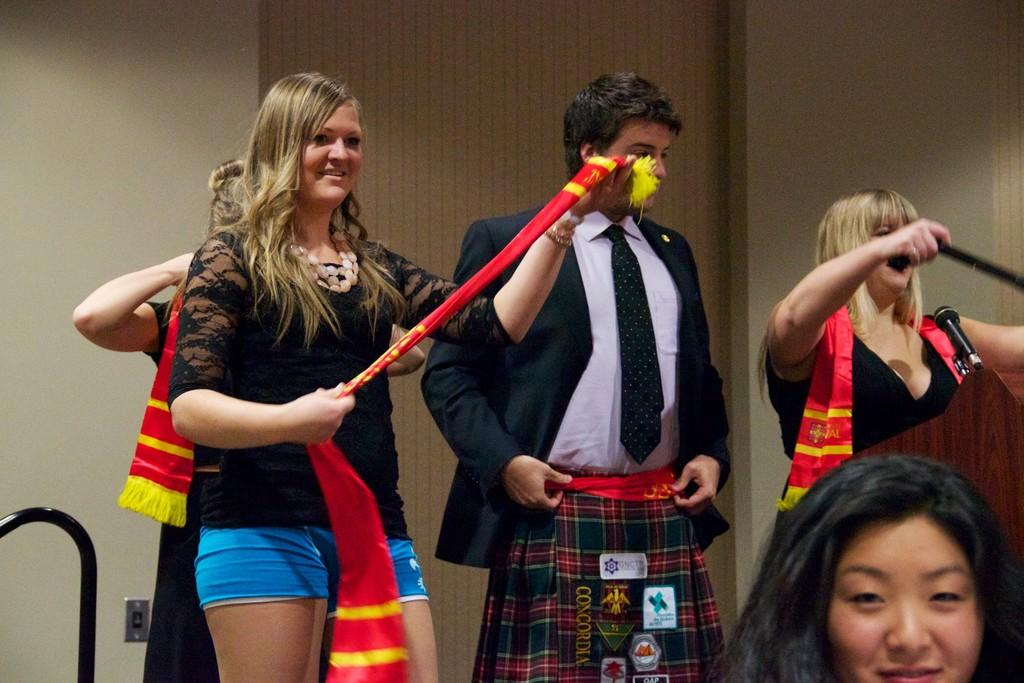How many people are in the image? There are people in the image, but the exact number is not specified. What are the people holding in their hands? Some people are holding something in their hands, but the specific objects are not mentioned. What can be seen on the right side of the image? There is a podium with a mic on the right side of the image. What is visible in the background of the image? There is a wall in the background of the image. What type of health advice is being given by the stranger in the image? There is no stranger present in the image, and therefore no health advice can be given. 